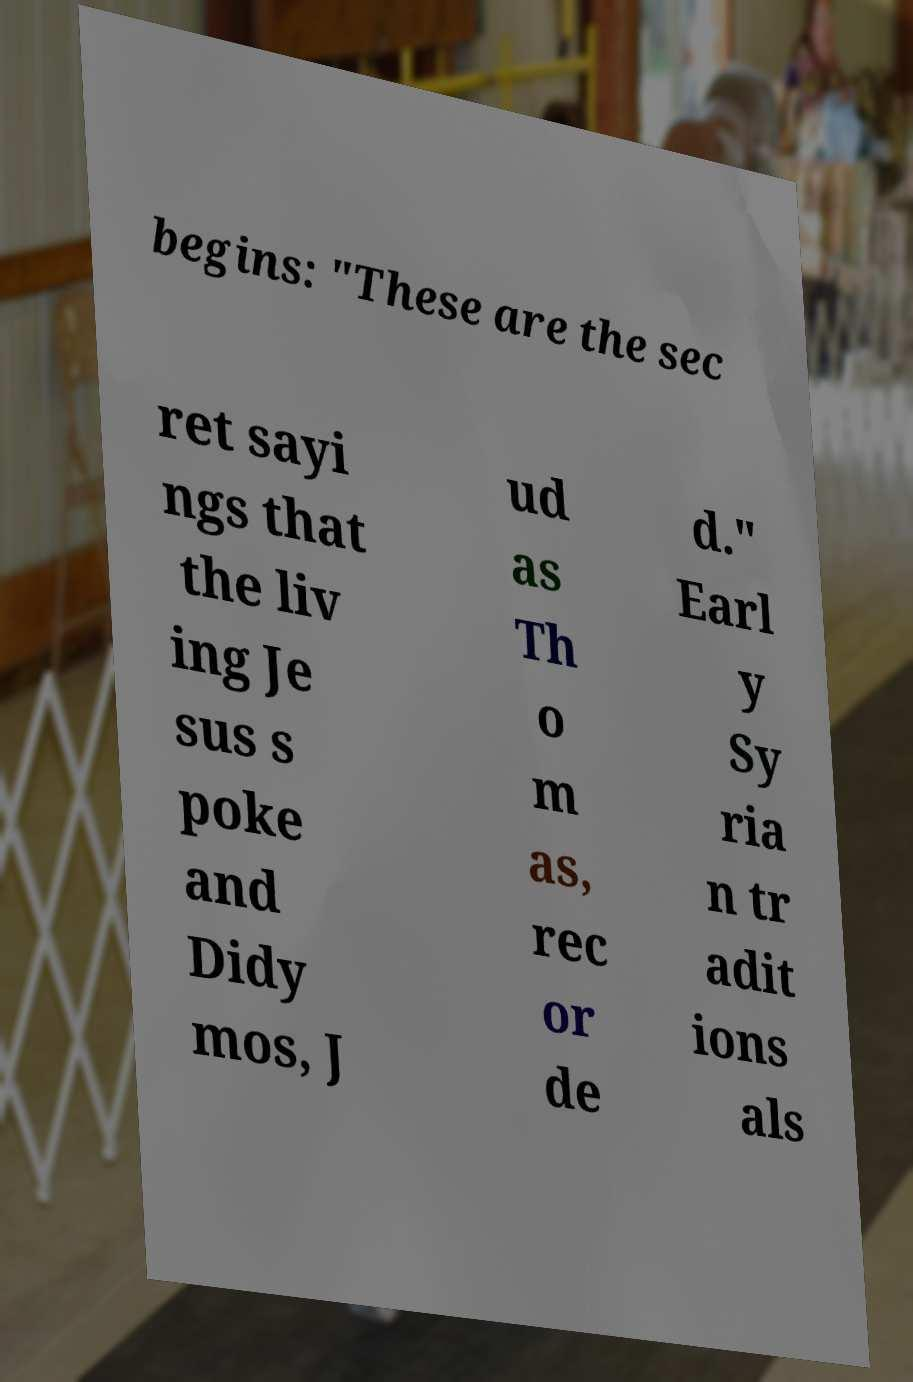Could you extract and type out the text from this image? begins: "These are the sec ret sayi ngs that the liv ing Je sus s poke and Didy mos, J ud as Th o m as, rec or de d." Earl y Sy ria n tr adit ions als 